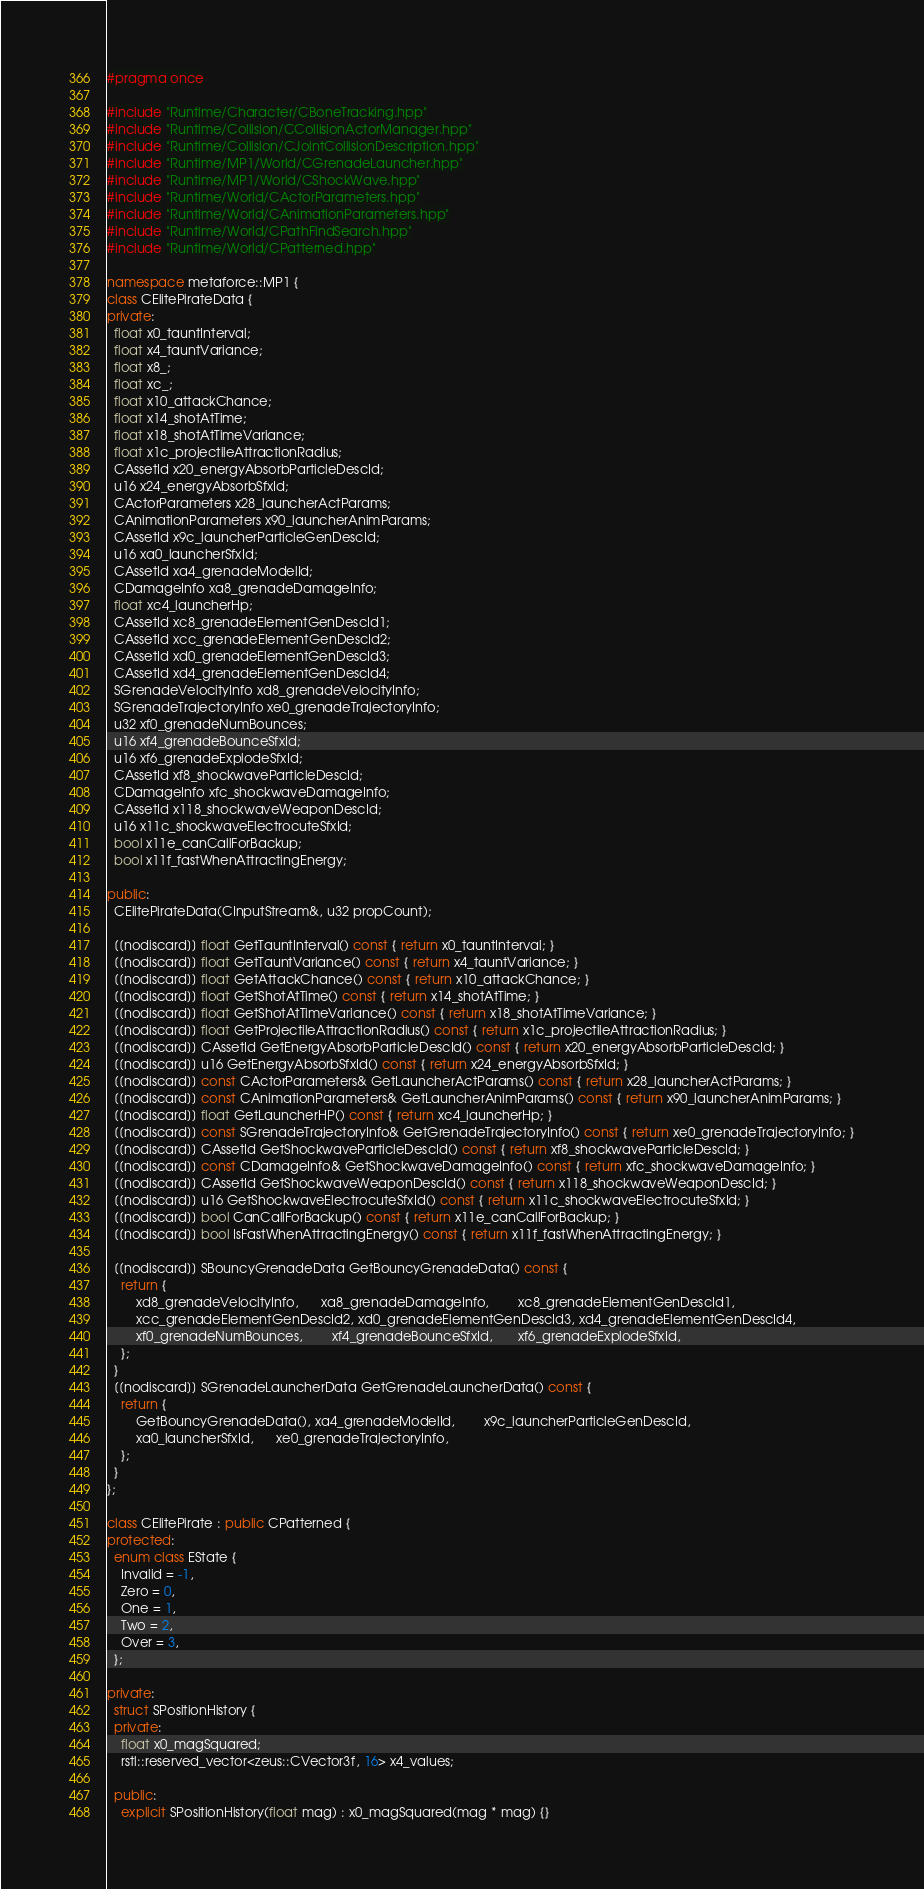<code> <loc_0><loc_0><loc_500><loc_500><_C++_>#pragma once

#include "Runtime/Character/CBoneTracking.hpp"
#include "Runtime/Collision/CCollisionActorManager.hpp"
#include "Runtime/Collision/CJointCollisionDescription.hpp"
#include "Runtime/MP1/World/CGrenadeLauncher.hpp"
#include "Runtime/MP1/World/CShockWave.hpp"
#include "Runtime/World/CActorParameters.hpp"
#include "Runtime/World/CAnimationParameters.hpp"
#include "Runtime/World/CPathFindSearch.hpp"
#include "Runtime/World/CPatterned.hpp"

namespace metaforce::MP1 {
class CElitePirateData {
private:
  float x0_tauntInterval;
  float x4_tauntVariance;
  float x8_;
  float xc_;
  float x10_attackChance;
  float x14_shotAtTime;
  float x18_shotAtTimeVariance;
  float x1c_projectileAttractionRadius;
  CAssetId x20_energyAbsorbParticleDescId;
  u16 x24_energyAbsorbSfxId;
  CActorParameters x28_launcherActParams;
  CAnimationParameters x90_launcherAnimParams;
  CAssetId x9c_launcherParticleGenDescId;
  u16 xa0_launcherSfxId;
  CAssetId xa4_grenadeModelId;
  CDamageInfo xa8_grenadeDamageInfo;
  float xc4_launcherHp;
  CAssetId xc8_grenadeElementGenDescId1;
  CAssetId xcc_grenadeElementGenDescId2;
  CAssetId xd0_grenadeElementGenDescId3;
  CAssetId xd4_grenadeElementGenDescId4;
  SGrenadeVelocityInfo xd8_grenadeVelocityInfo;
  SGrenadeTrajectoryInfo xe0_grenadeTrajectoryInfo;
  u32 xf0_grenadeNumBounces;
  u16 xf4_grenadeBounceSfxId;
  u16 xf6_grenadeExplodeSfxId;
  CAssetId xf8_shockwaveParticleDescId;
  CDamageInfo xfc_shockwaveDamageInfo;
  CAssetId x118_shockwaveWeaponDescId;
  u16 x11c_shockwaveElectrocuteSfxId;
  bool x11e_canCallForBackup;
  bool x11f_fastWhenAttractingEnergy;

public:
  CElitePirateData(CInputStream&, u32 propCount);

  [[nodiscard]] float GetTauntInterval() const { return x0_tauntInterval; }
  [[nodiscard]] float GetTauntVariance() const { return x4_tauntVariance; }
  [[nodiscard]] float GetAttackChance() const { return x10_attackChance; }
  [[nodiscard]] float GetShotAtTime() const { return x14_shotAtTime; }
  [[nodiscard]] float GetShotAtTimeVariance() const { return x18_shotAtTimeVariance; }
  [[nodiscard]] float GetProjectileAttractionRadius() const { return x1c_projectileAttractionRadius; }
  [[nodiscard]] CAssetId GetEnergyAbsorbParticleDescId() const { return x20_energyAbsorbParticleDescId; }
  [[nodiscard]] u16 GetEnergyAbsorbSfxId() const { return x24_energyAbsorbSfxId; }
  [[nodiscard]] const CActorParameters& GetLauncherActParams() const { return x28_launcherActParams; }
  [[nodiscard]] const CAnimationParameters& GetLauncherAnimParams() const { return x90_launcherAnimParams; }
  [[nodiscard]] float GetLauncherHP() const { return xc4_launcherHp; }
  [[nodiscard]] const SGrenadeTrajectoryInfo& GetGrenadeTrajectoryInfo() const { return xe0_grenadeTrajectoryInfo; }
  [[nodiscard]] CAssetId GetShockwaveParticleDescId() const { return xf8_shockwaveParticleDescId; }
  [[nodiscard]] const CDamageInfo& GetShockwaveDamageInfo() const { return xfc_shockwaveDamageInfo; }
  [[nodiscard]] CAssetId GetShockwaveWeaponDescId() const { return x118_shockwaveWeaponDescId; }
  [[nodiscard]] u16 GetShockwaveElectrocuteSfxId() const { return x11c_shockwaveElectrocuteSfxId; }
  [[nodiscard]] bool CanCallForBackup() const { return x11e_canCallForBackup; }
  [[nodiscard]] bool IsFastWhenAttractingEnergy() const { return x11f_fastWhenAttractingEnergy; }

  [[nodiscard]] SBouncyGrenadeData GetBouncyGrenadeData() const {
    return {
        xd8_grenadeVelocityInfo,      xa8_grenadeDamageInfo,        xc8_grenadeElementGenDescId1,
        xcc_grenadeElementGenDescId2, xd0_grenadeElementGenDescId3, xd4_grenadeElementGenDescId4,
        xf0_grenadeNumBounces,        xf4_grenadeBounceSfxId,       xf6_grenadeExplodeSfxId,
    };
  }
  [[nodiscard]] SGrenadeLauncherData GetGrenadeLauncherData() const {
    return {
        GetBouncyGrenadeData(), xa4_grenadeModelId,        x9c_launcherParticleGenDescId,
        xa0_launcherSfxId,      xe0_grenadeTrajectoryInfo,
    };
  }
};

class CElitePirate : public CPatterned {
protected:
  enum class EState {
    Invalid = -1,
    Zero = 0,
    One = 1,
    Two = 2,
    Over = 3,
  };

private:
  struct SPositionHistory {
  private:
    float x0_magSquared;
    rstl::reserved_vector<zeus::CVector3f, 16> x4_values;

  public:
    explicit SPositionHistory(float mag) : x0_magSquared(mag * mag) {}</code> 